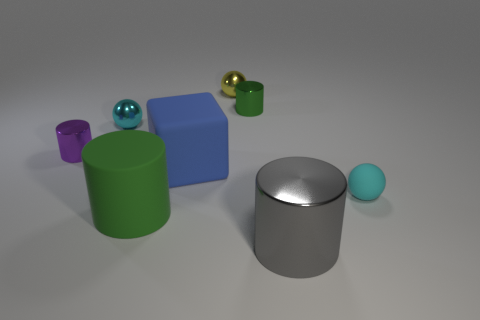Subtract all yellow cylinders. Subtract all red blocks. How many cylinders are left? 4 Add 2 big cyan metal spheres. How many objects exist? 10 Subtract all spheres. How many objects are left? 5 Add 4 large gray metallic things. How many large gray metallic things are left? 5 Add 2 big green metal cylinders. How many big green metal cylinders exist? 2 Subtract 0 brown blocks. How many objects are left? 8 Subtract all big blue blocks. Subtract all big rubber things. How many objects are left? 5 